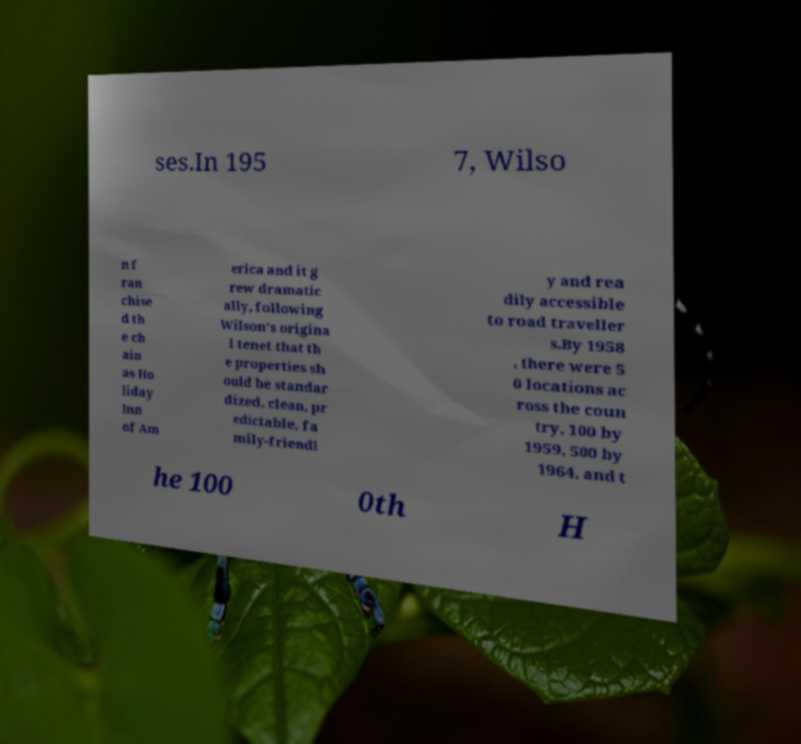For documentation purposes, I need the text within this image transcribed. Could you provide that? ses.In 195 7, Wilso n f ran chise d th e ch ain as Ho liday Inn of Am erica and it g rew dramatic ally, following Wilson's origina l tenet that th e properties sh ould be standar dized, clean, pr edictable, fa mily-friendl y and rea dily accessible to road traveller s.By 1958 , there were 5 0 locations ac ross the coun try, 100 by 1959, 500 by 1964, and t he 100 0th H 